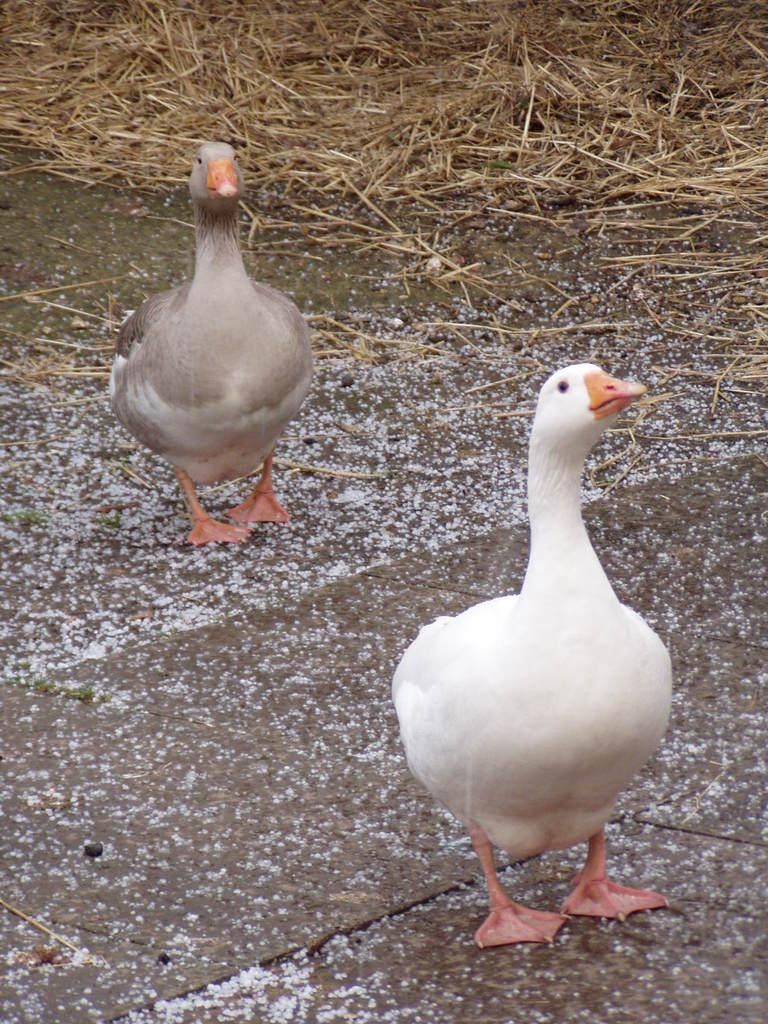How many ducks are in the image? There are two ducks in the image. What colors are the ducks? One duck is white, and the other is cement-colored. What type of vegetation is present in the image? There is dry grass in the image. What type of surface can be seen in the image? There is a solid surface in the image. What type of door can be seen in the image? There is no door present in the image; it features two ducks and dry grass on a solid surface. 